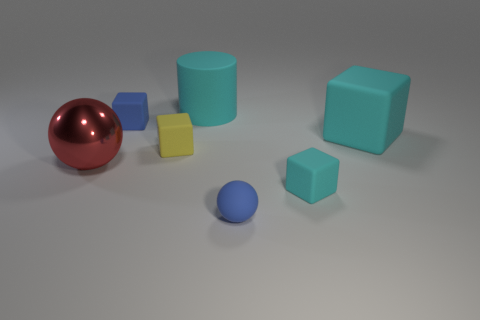What is the spatial arrangement of the objects, and does it suggest any particular pattern or purpose? The objects are placed rather sporadically across a flat surface with no apparent pattern. There's no obvious purpose visible from the arrangement itself; it seems to be a random distribution of geometric shapes primarily for visual or illustrative purposes. 